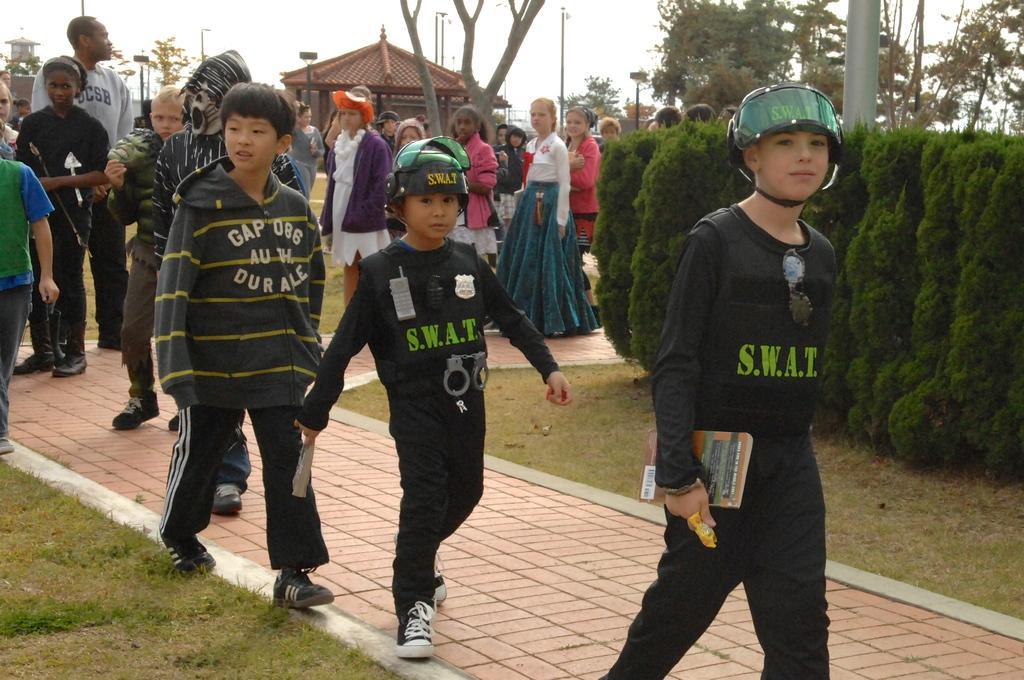Describe this image in one or two sentences. In this image we can see some people are walking, two small houses, some people are standing, some poles, some people are holding some objects, some trees, bushes, plants and grass on the ground. At the top there is the sky. 